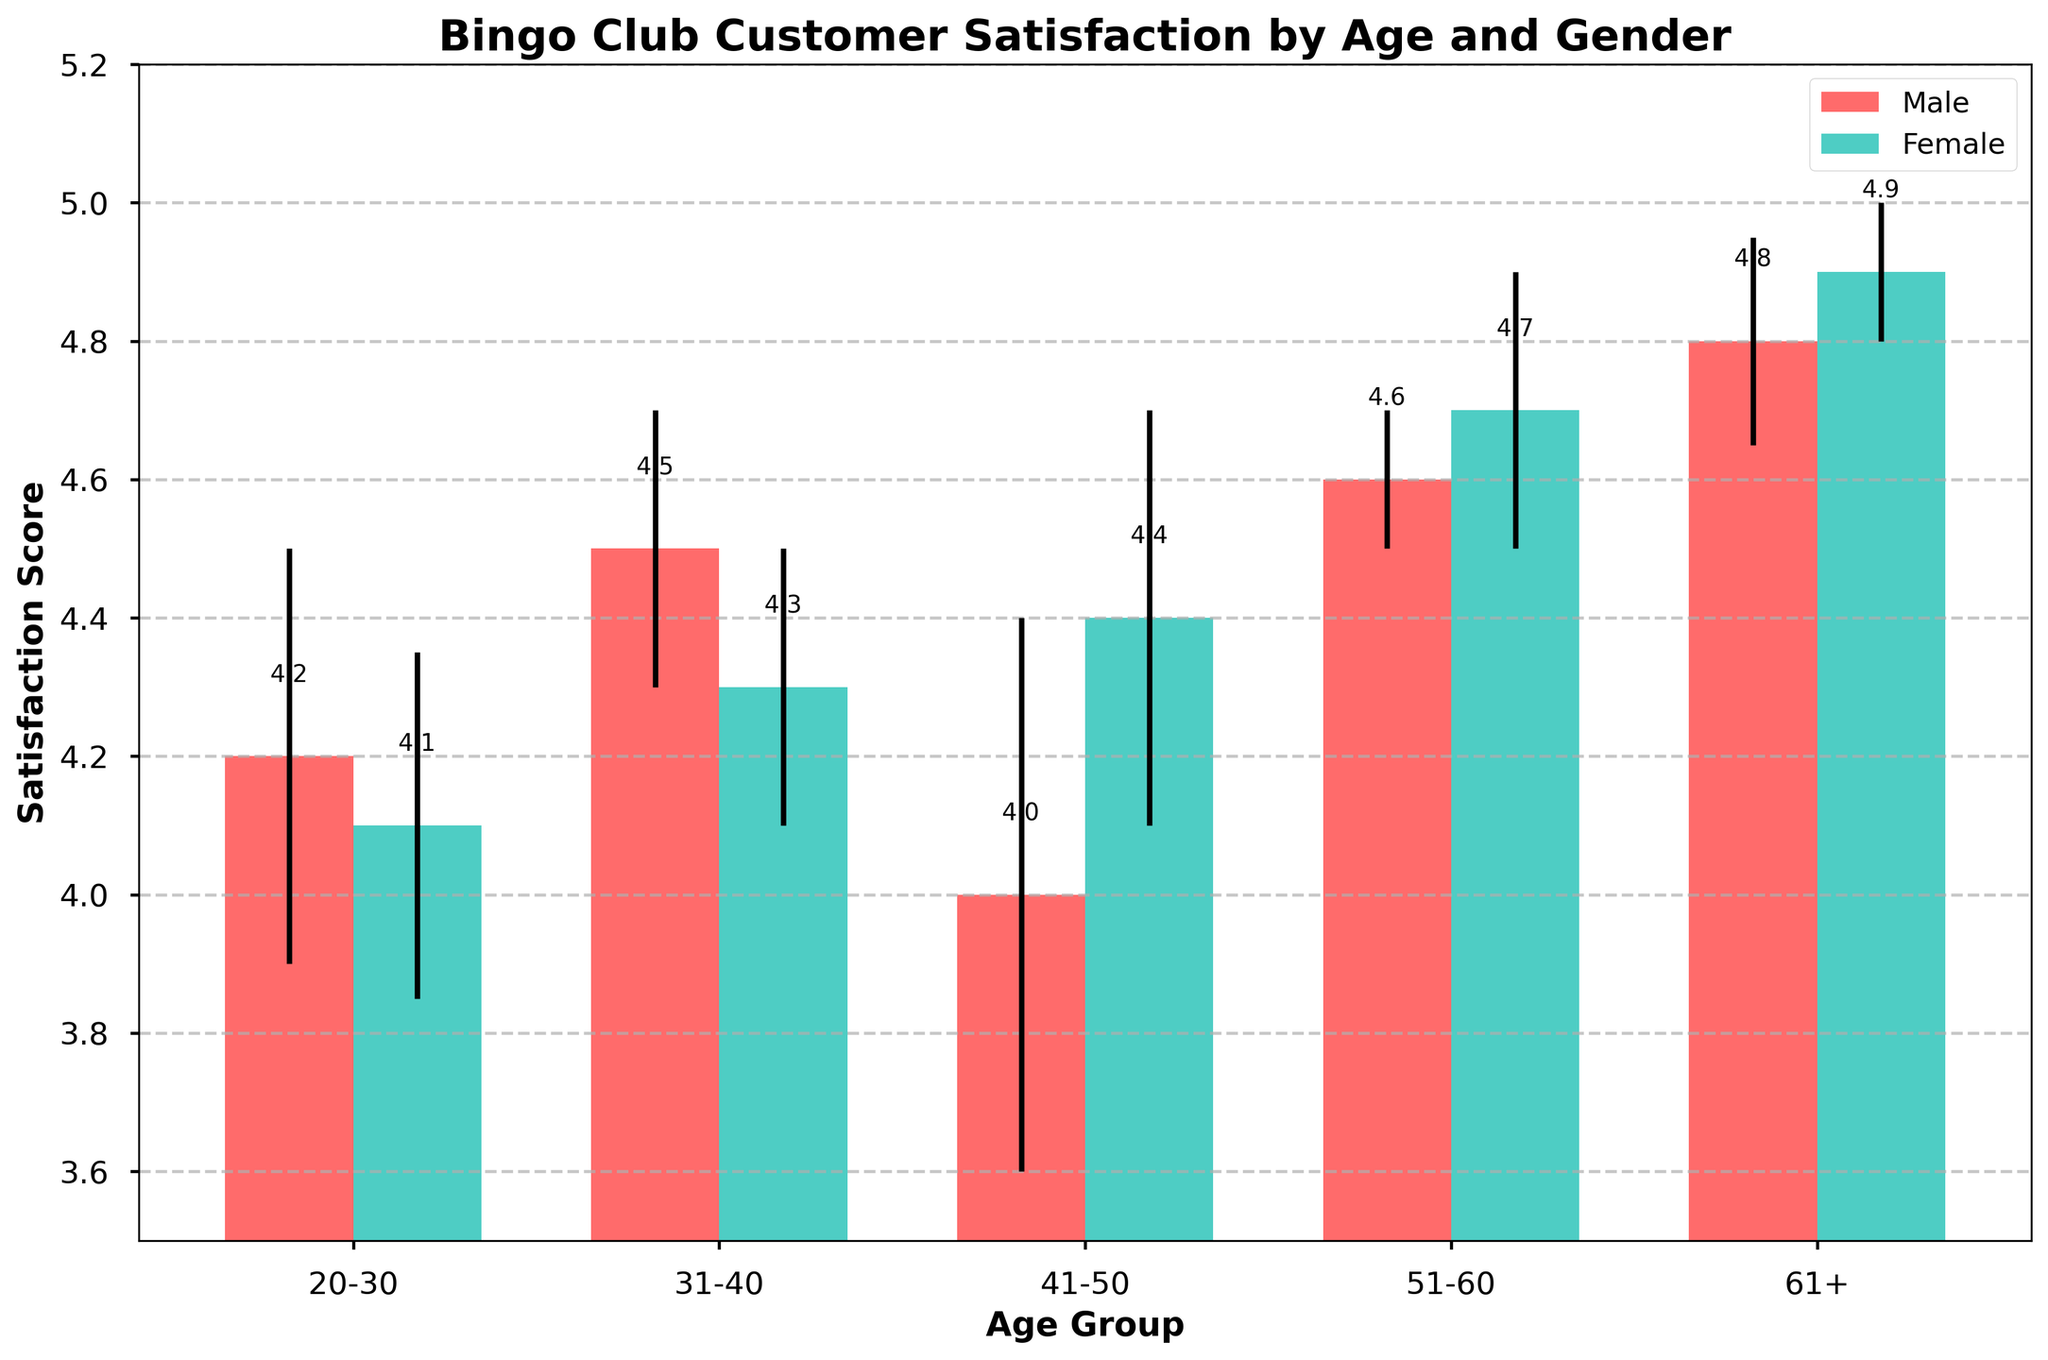What is the title of the figure? The title is displayed at the top of the figure.
Answer: Bingo Club Customer Satisfaction by Age and Gender How many different age groups are there in the figure? Count the number of distinct age group labels on the x-axis.
Answer: 5 Which gender has the highest satisfaction score for the 61+ age group? Compare the satisfaction scores of males and females for the 61+ age group by looking at the heights of the bars.
Answer: Female What is the mean satisfaction score for females aged 41-50? Locate the bar corresponding to females aged 41-50 and read its height.
Answer: 4.4 What is the difference in mean satisfaction scores between males and females aged 31-40? Subtract the mean satisfaction score for males from that of females aged 31-40.
Answer: 4.5 - 4.3 = 0.2 Which age group for males has the largest error margin? Examine the error bars for all male age groups and identify the one with the largest length.
Answer: Male (41-50) Which gender shows a generally increasing trend in satisfaction scores with age? Observe the overall trend in the bars' heights for each gender as age increases.
Answer: Female What is the average satisfaction score for males across all age groups? Sum the mean satisfaction scores for all male age groups and divide by the number of groups.
Answer: (4.2 + 4.5 + 4.0 + 4.6 + 4.8) / 5 = 4.42 What is the median satisfaction score for females across all age groups? List the mean satisfaction scores for females in ascending order and pick the middle value.
Answer: 4.4 Which age group has the smallest difference in satisfaction scores between males and females? Calculate the absolute differences in satisfaction scores for each age group and find the smallest one.
Answer: 51-60 